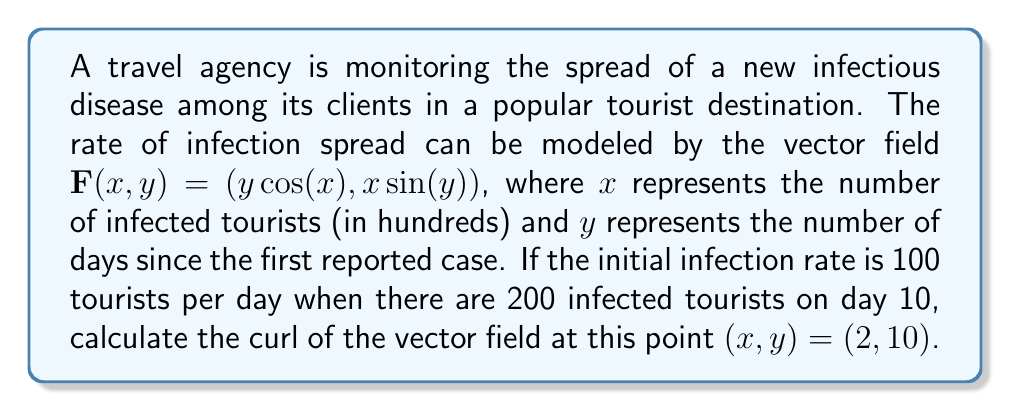Help me with this question. To solve this problem, we need to calculate the curl of the given vector field at the specified point. The curl of a two-dimensional vector field $\mathbf{F}(x, y) = (P(x,y), Q(x,y))$ is defined as:

$$\text{curl }\mathbf{F} = \frac{\partial Q}{\partial x} - \frac{\partial P}{\partial y}$$

For our vector field $\mathbf{F}(x, y) = (y\cos(x), x\sin(y))$, we have:
$P(x,y) = y\cos(x)$
$Q(x,y) = x\sin(y)$

Step 1: Calculate $\frac{\partial Q}{\partial x}$
$$\frac{\partial Q}{\partial x} = \frac{\partial}{\partial x}(x\sin(y)) = \sin(y)$$

Step 2: Calculate $\frac{\partial P}{\partial y}$
$$\frac{\partial P}{\partial y} = \frac{\partial}{\partial y}(y\cos(x)) = \cos(x)$$

Step 3: Calculate the curl
$$\text{curl }\mathbf{F} = \frac{\partial Q}{\partial x} - \frac{\partial P}{\partial y} = \sin(y) - \cos(x)$$

Step 4: Evaluate the curl at the point $(x, y) = (2, 10)$
$$\text{curl }\mathbf{F}(2, 10) = \sin(10) - \cos(2)$$

Step 5: Calculate the final result
$$\text{curl }\mathbf{F}(2, 10) = -0.5440 - (-0.4161) = -0.1279$$

The negative curl indicates that the disease spread is rotating clockwise at this point, which could suggest a decreasing rate of infection among the agency's clients.
Answer: The curl of the vector field at the point $(x, y) = (2, 10)$ is approximately $-0.1279$. 